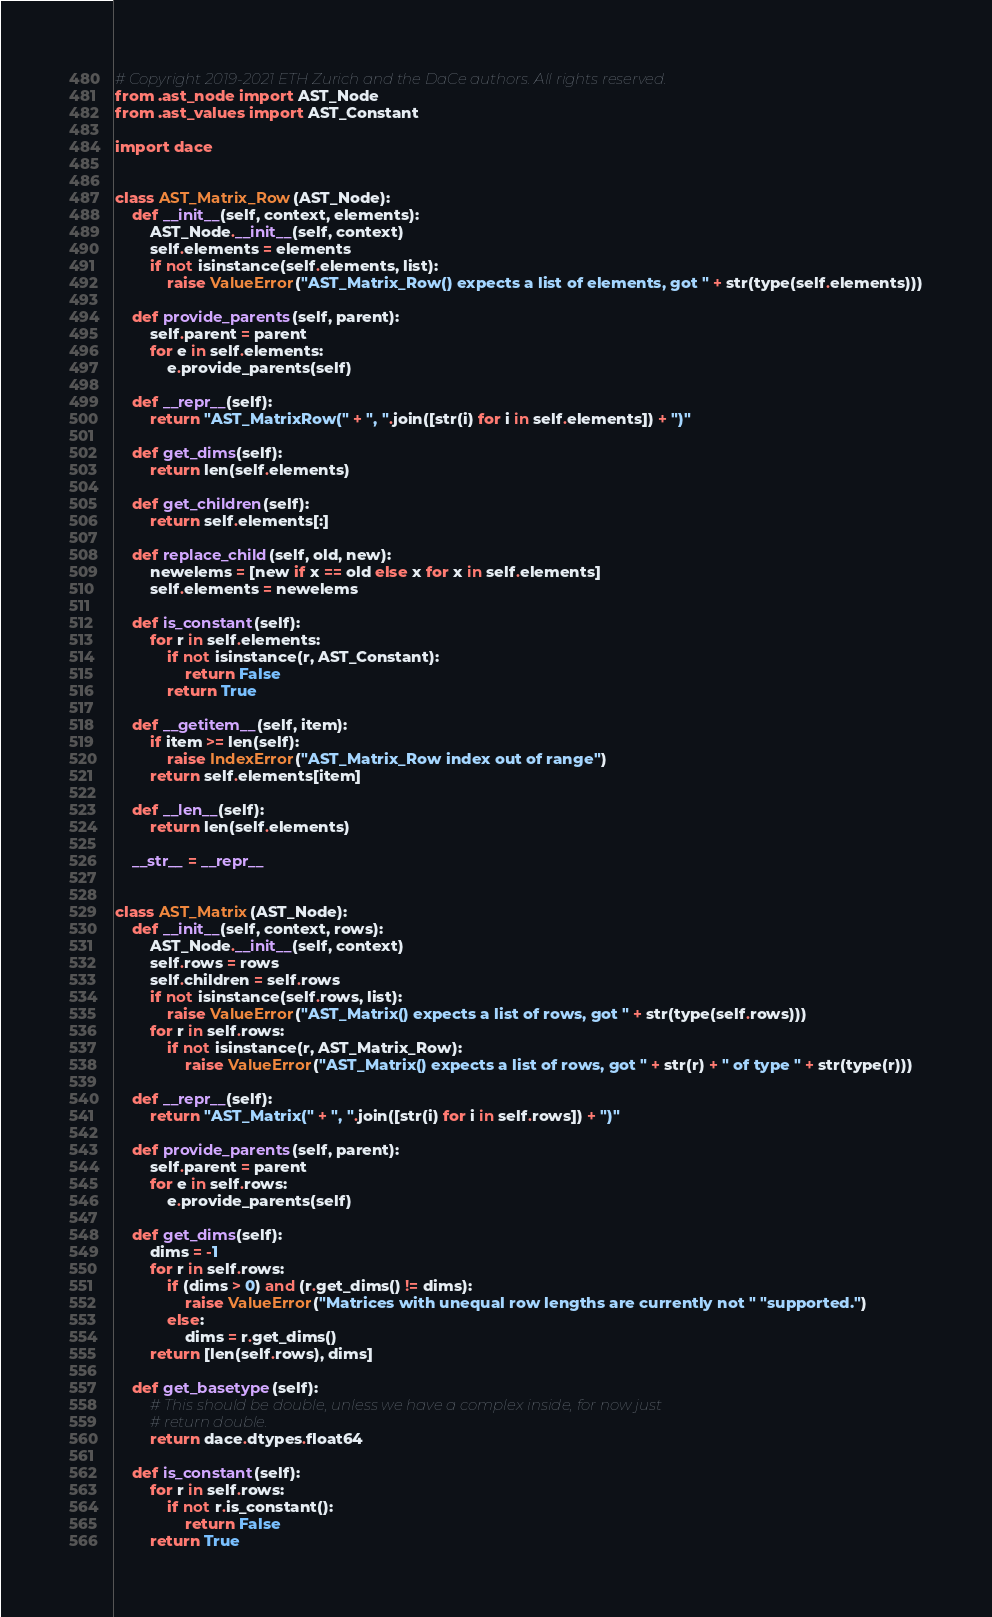<code> <loc_0><loc_0><loc_500><loc_500><_Python_># Copyright 2019-2021 ETH Zurich and the DaCe authors. All rights reserved.
from .ast_node import AST_Node
from .ast_values import AST_Constant

import dace


class AST_Matrix_Row(AST_Node):
    def __init__(self, context, elements):
        AST_Node.__init__(self, context)
        self.elements = elements
        if not isinstance(self.elements, list):
            raise ValueError("AST_Matrix_Row() expects a list of elements, got " + str(type(self.elements)))

    def provide_parents(self, parent):
        self.parent = parent
        for e in self.elements:
            e.provide_parents(self)

    def __repr__(self):
        return "AST_MatrixRow(" + ", ".join([str(i) for i in self.elements]) + ")"

    def get_dims(self):
        return len(self.elements)

    def get_children(self):
        return self.elements[:]

    def replace_child(self, old, new):
        newelems = [new if x == old else x for x in self.elements]
        self.elements = newelems

    def is_constant(self):
        for r in self.elements:
            if not isinstance(r, AST_Constant):
                return False
            return True

    def __getitem__(self, item):
        if item >= len(self):
            raise IndexError("AST_Matrix_Row index out of range")
        return self.elements[item]

    def __len__(self):
        return len(self.elements)

    __str__ = __repr__


class AST_Matrix(AST_Node):
    def __init__(self, context, rows):
        AST_Node.__init__(self, context)
        self.rows = rows
        self.children = self.rows
        if not isinstance(self.rows, list):
            raise ValueError("AST_Matrix() expects a list of rows, got " + str(type(self.rows)))
        for r in self.rows:
            if not isinstance(r, AST_Matrix_Row):
                raise ValueError("AST_Matrix() expects a list of rows, got " + str(r) + " of type " + str(type(r)))

    def __repr__(self):
        return "AST_Matrix(" + ", ".join([str(i) for i in self.rows]) + ")"

    def provide_parents(self, parent):
        self.parent = parent
        for e in self.rows:
            e.provide_parents(self)

    def get_dims(self):
        dims = -1
        for r in self.rows:
            if (dims > 0) and (r.get_dims() != dims):
                raise ValueError("Matrices with unequal row lengths are currently not " "supported.")
            else:
                dims = r.get_dims()
        return [len(self.rows), dims]

    def get_basetype(self):
        # This should be double, unless we have a complex inside, for now just
        # return double.
        return dace.dtypes.float64

    def is_constant(self):
        for r in self.rows:
            if not r.is_constant():
                return False
        return True
</code> 